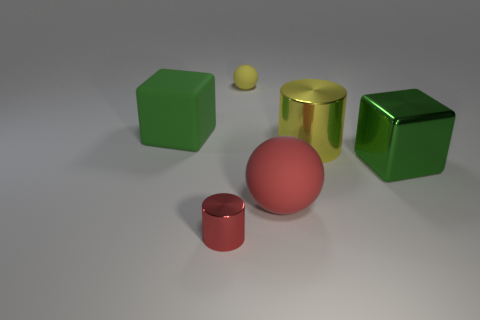Do the objects appear to be thrown randomly or arranged deliberately? The objects seem to be deliberately arranged, with adequate space between them to distinguish their shapes and colors. This orderly display likely serves to showcase the differences and similarities of geometric forms.  What could be the purpose of arranging these objects in such a manner? Arranging these objects deliberately could serve educational purposes, like a visualization for a geometry lesson, or be part of a demonstration showcasing rendering techniques in three-dimensional modeling software. 